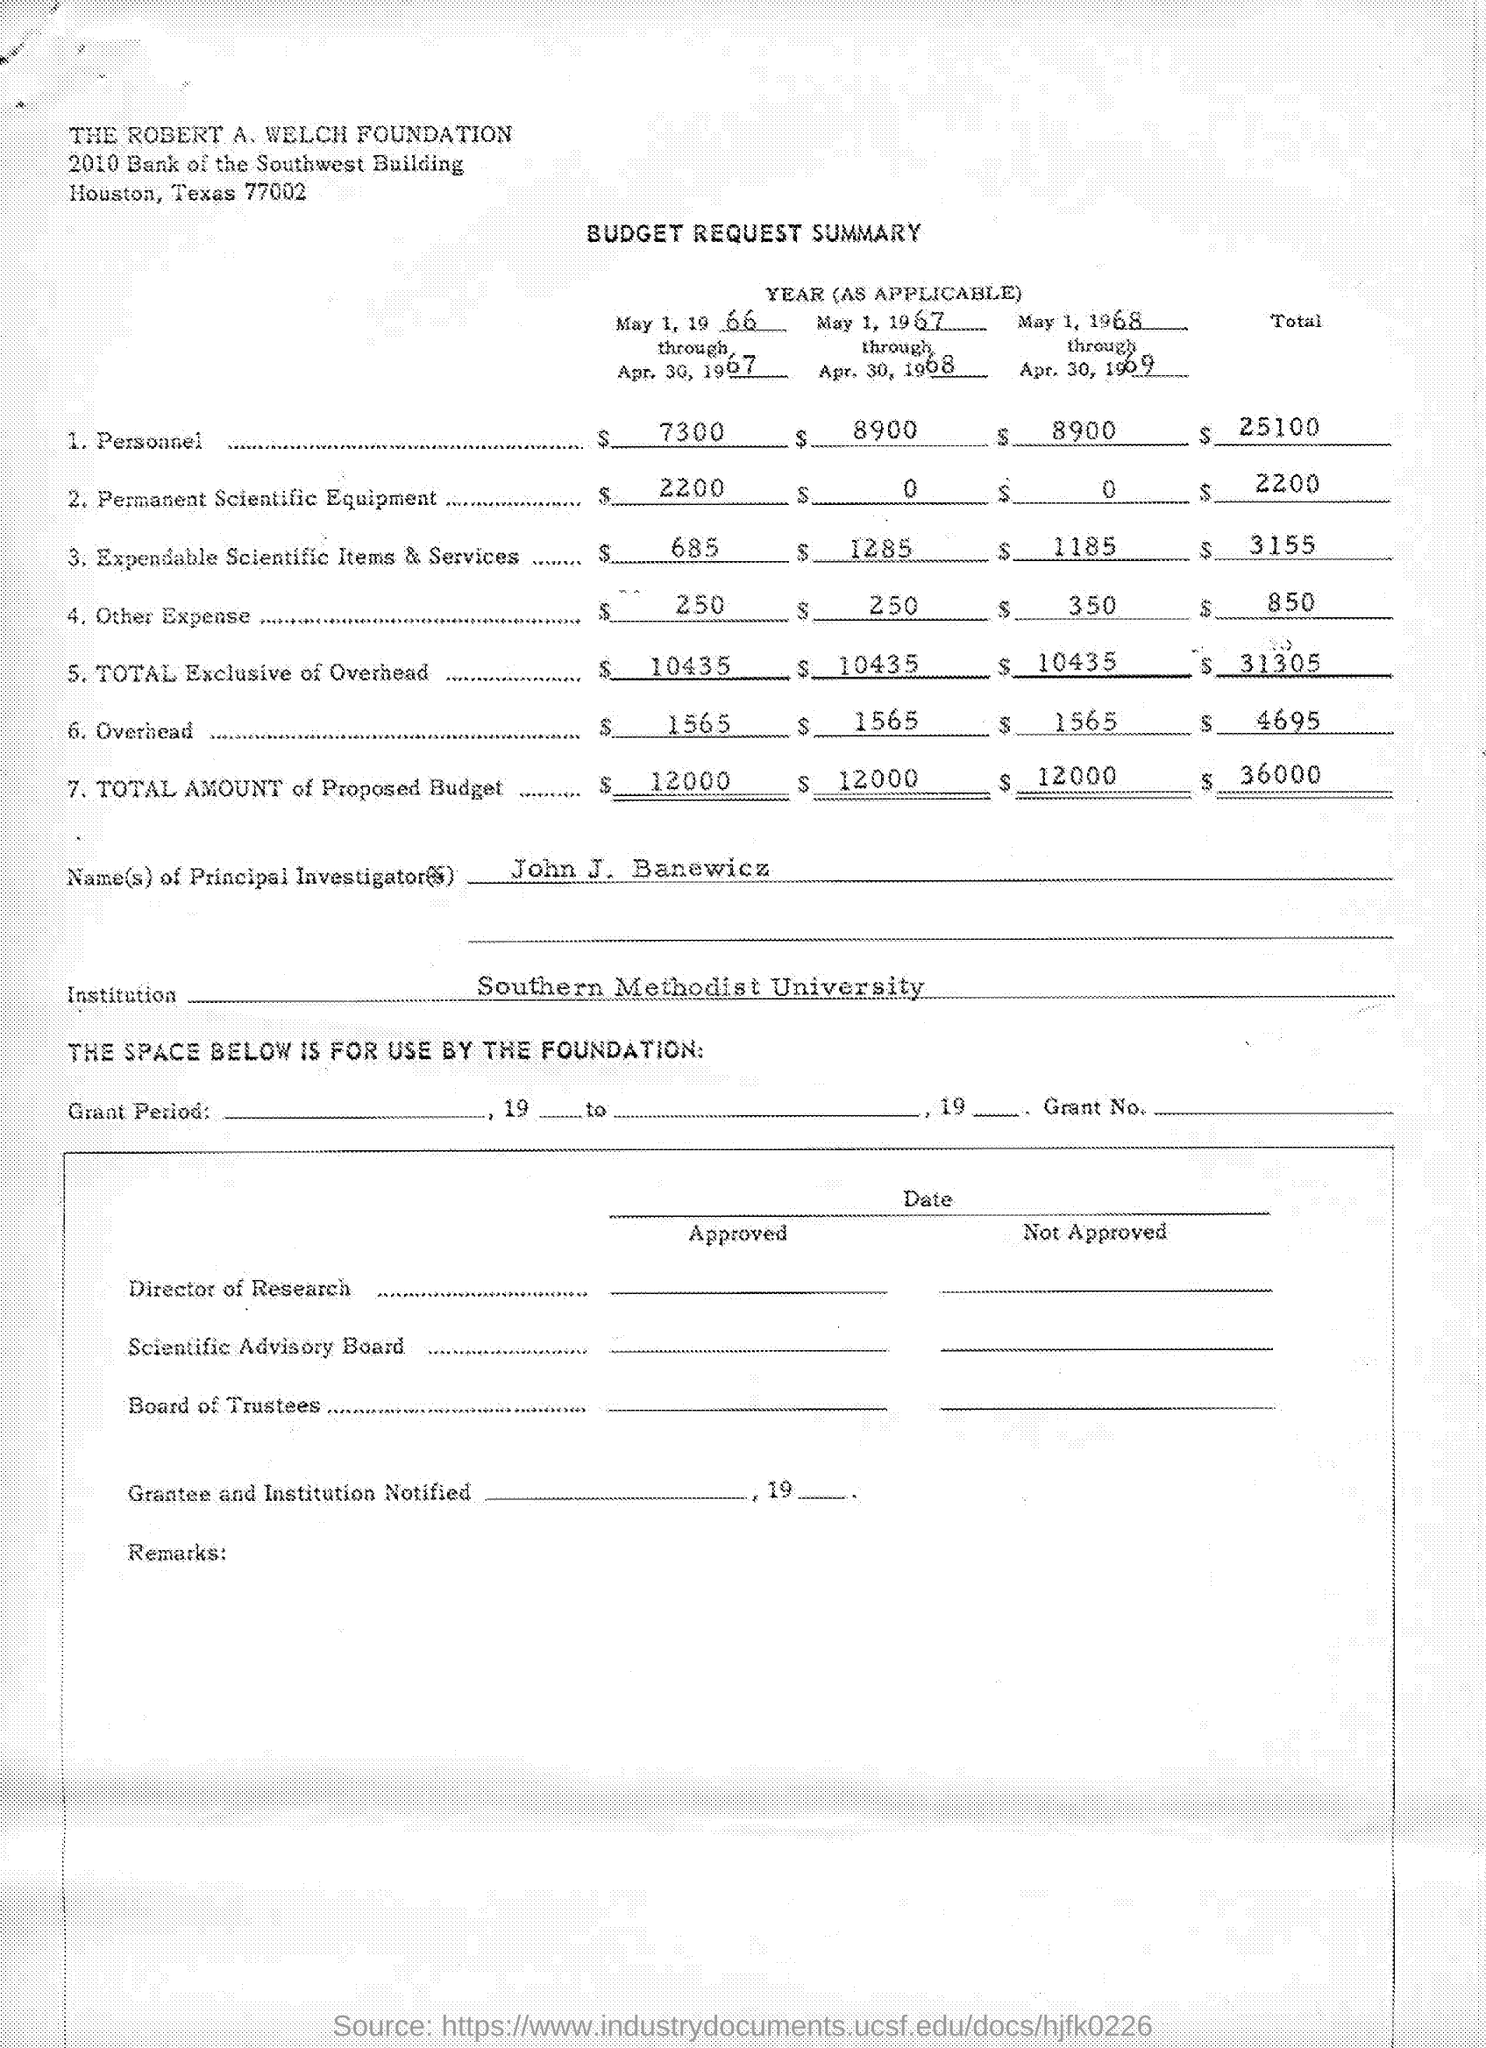List a handful of essential elements in this visual. The principal investigator's name is John J. Banewicz. The title of the document is "Budget Request Summary. The budget allocated for the purchase of permanent scientific equipment for the period of May 1, 1966 to April 30, 1967 was $2,200. The other expenses budget for the period of May 1, 1966 to April 30, 1967 was $250. The budget for the period of May 1, 1966 through April 30, 1967 was $10,435, exclusive of overhead costs. 